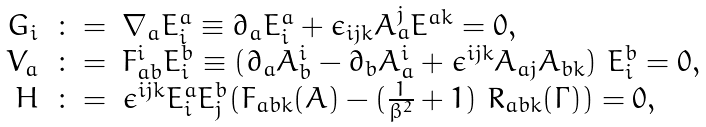Convert formula to latex. <formula><loc_0><loc_0><loc_500><loc_500>\begin{array} { r c l } G _ { i } & \colon = & \nabla _ { a } E ^ { a } _ { i } \equiv \partial _ { a } E ^ { a } _ { i } + \epsilon _ { i j k } A _ { a } ^ { j } E ^ { a k } = 0 , \\ V _ { a } & \colon = & F _ { a b } ^ { i } E ^ { b } _ { i } \equiv ( \partial _ { a } A _ { b } ^ { i } - \partial _ { b } A _ { a } ^ { i } + \epsilon ^ { i j k } A _ { a j } A _ { b k } ) \ E ^ { b } _ { i } = 0 , \\ H & \colon = & \epsilon ^ { i j k } E ^ { a } _ { i } E ^ { b } _ { j } ( F _ { a b k } ( A ) - ( \frac { 1 } { \beta ^ { 2 } } + 1 ) \ R _ { a b k } ( \Gamma ) ) = 0 , \end{array}</formula> 